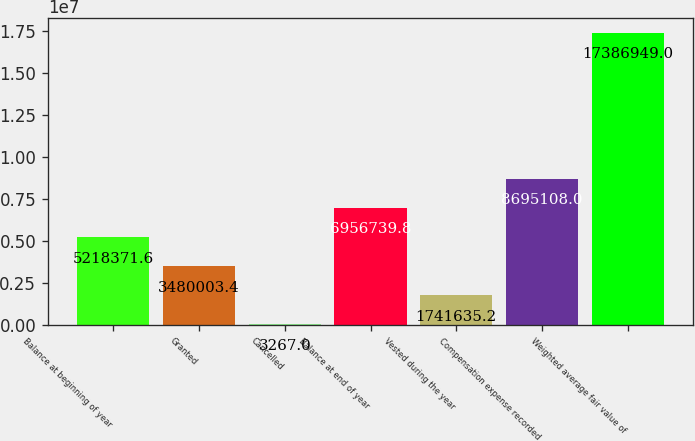<chart> <loc_0><loc_0><loc_500><loc_500><bar_chart><fcel>Balance at beginning of year<fcel>Granted<fcel>Cancelled<fcel>Balance at end of year<fcel>Vested during the year<fcel>Compensation expense recorded<fcel>Weighted average fair value of<nl><fcel>5.21837e+06<fcel>3.48e+06<fcel>3267<fcel>6.95674e+06<fcel>1.74164e+06<fcel>8.69511e+06<fcel>1.73869e+07<nl></chart> 